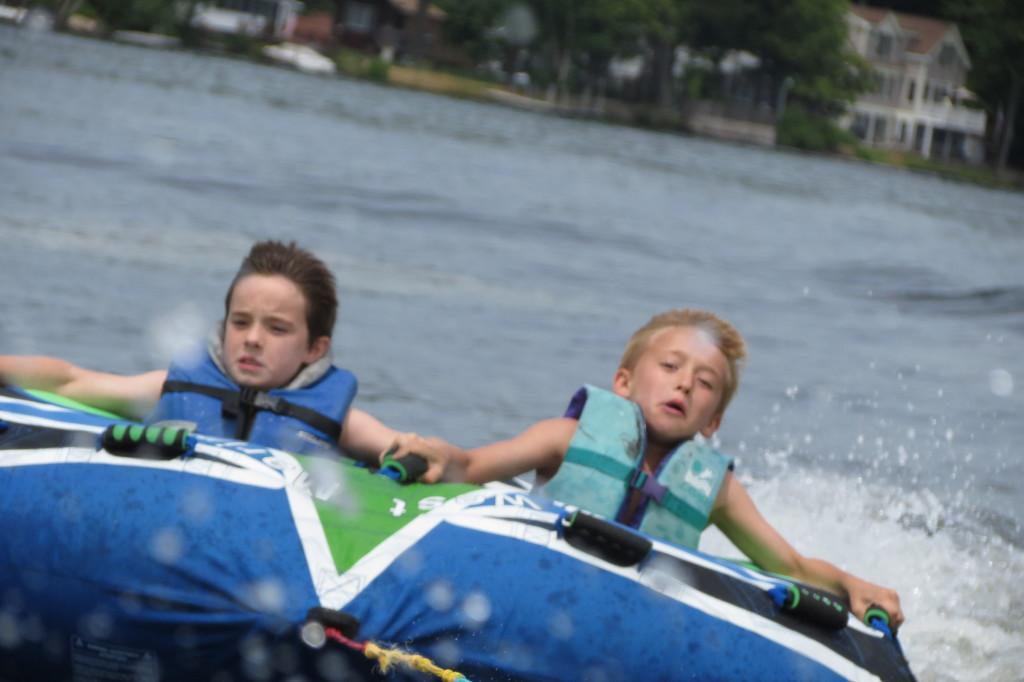In one or two sentences, can you explain what this image depicts? In this image we can see two boys sitting on the boat. In the background there is a lake, building and trees. 